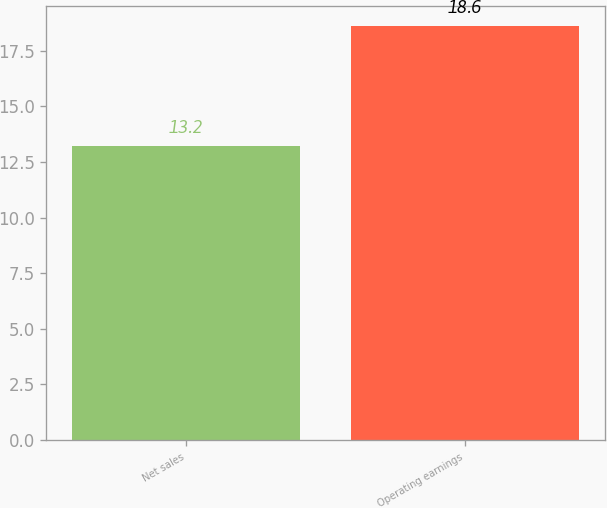Convert chart to OTSL. <chart><loc_0><loc_0><loc_500><loc_500><bar_chart><fcel>Net sales<fcel>Operating earnings<nl><fcel>13.2<fcel>18.6<nl></chart> 